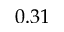<formula> <loc_0><loc_0><loc_500><loc_500>0 . 3 1</formula> 